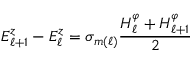<formula> <loc_0><loc_0><loc_500><loc_500>E _ { \ell + 1 } ^ { z } - E _ { \ell } ^ { z } = \sigma _ { m ( \ell ) } \frac { H _ { \ell } ^ { \varphi } + H _ { \ell + 1 } ^ { \varphi } } { 2 }</formula> 